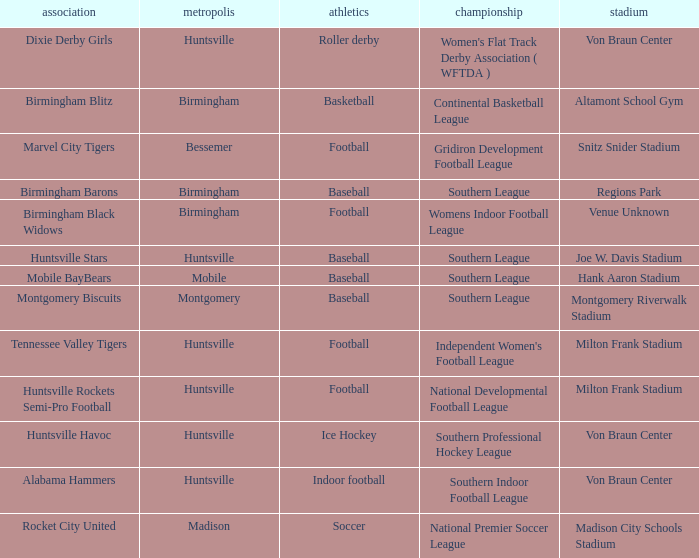Which sport had the club of the Montgomery Biscuits? Baseball. 